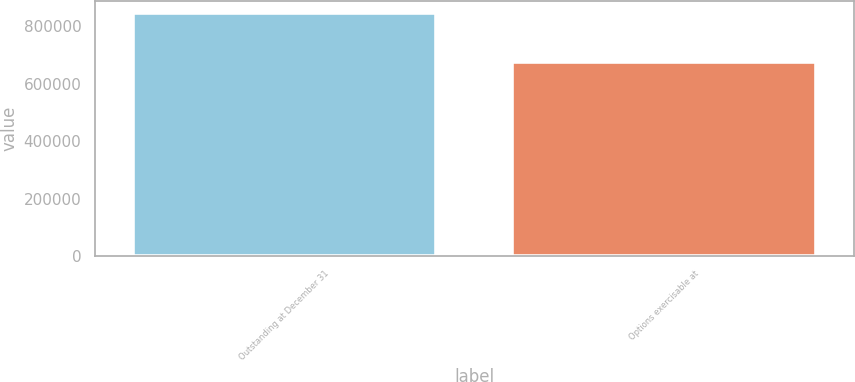<chart> <loc_0><loc_0><loc_500><loc_500><bar_chart><fcel>Outstanding at December 31<fcel>Options exercisable at<nl><fcel>847830<fcel>676202<nl></chart> 